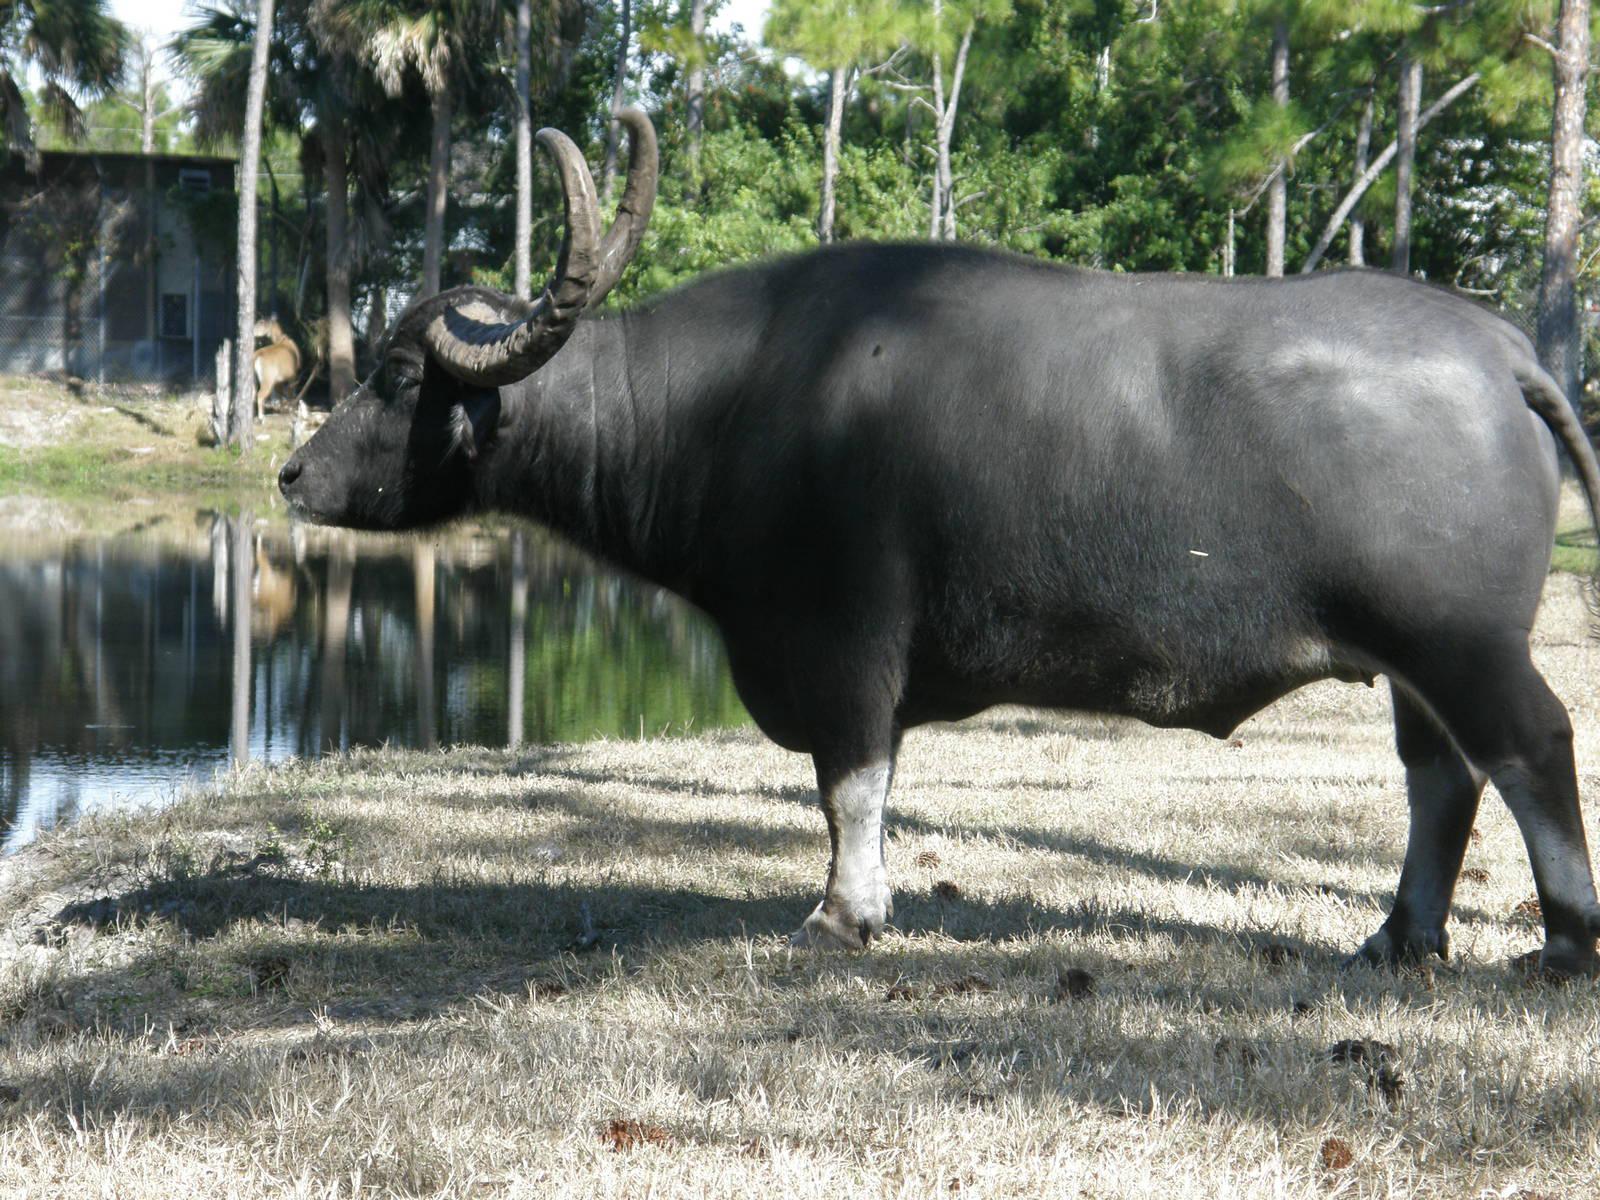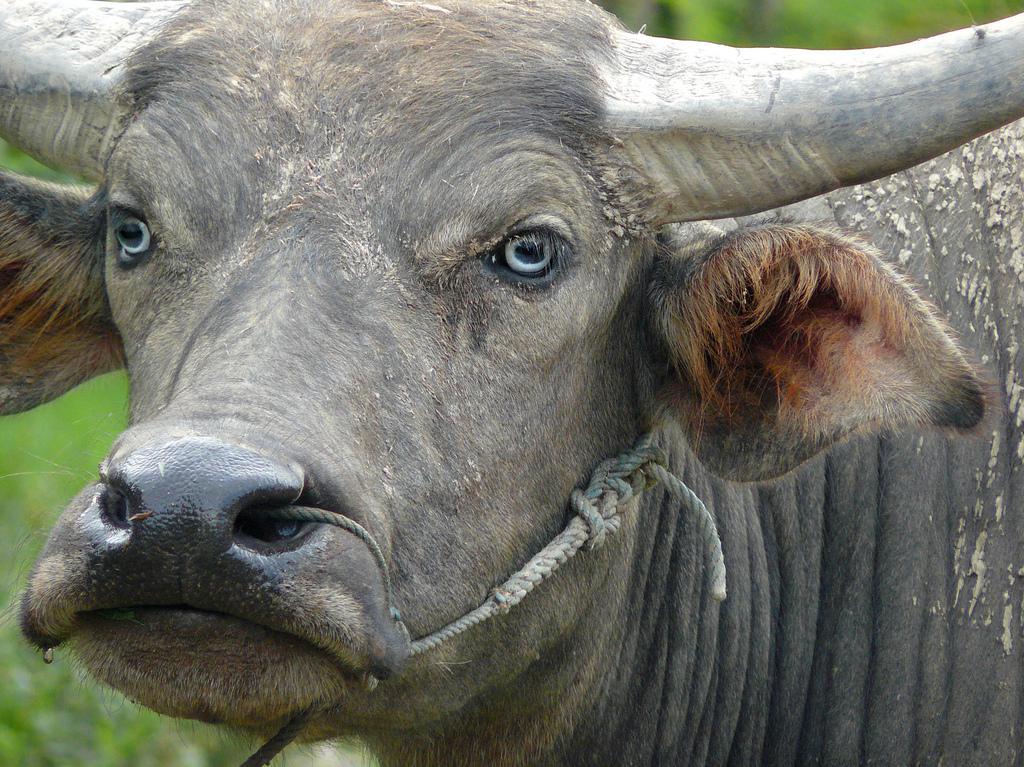The first image is the image on the left, the second image is the image on the right. Examine the images to the left and right. Is the description "An image shows one water buffalo standing in water that does not reach its chest." accurate? Answer yes or no. No. The first image is the image on the left, the second image is the image on the right. Given the left and right images, does the statement "An image contains a water buffalo standing on water." hold true? Answer yes or no. No. 